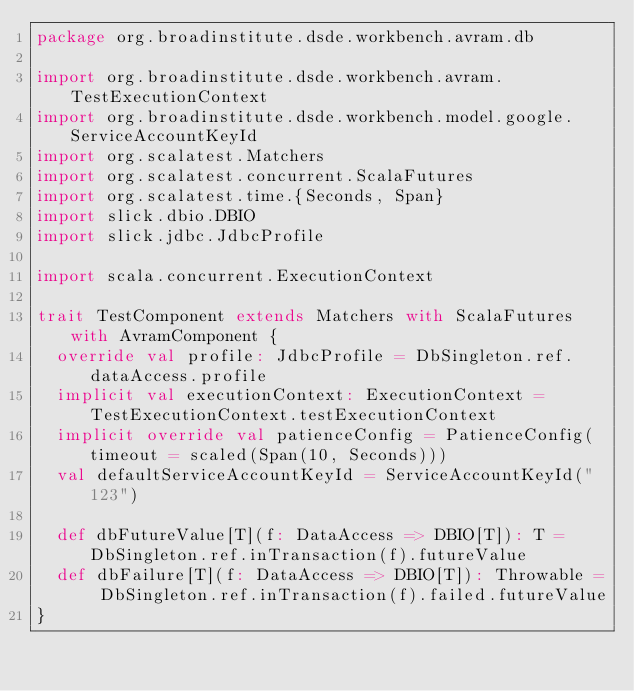Convert code to text. <code><loc_0><loc_0><loc_500><loc_500><_Scala_>package org.broadinstitute.dsde.workbench.avram.db

import org.broadinstitute.dsde.workbench.avram.TestExecutionContext
import org.broadinstitute.dsde.workbench.model.google.ServiceAccountKeyId
import org.scalatest.Matchers
import org.scalatest.concurrent.ScalaFutures
import org.scalatest.time.{Seconds, Span}
import slick.dbio.DBIO
import slick.jdbc.JdbcProfile

import scala.concurrent.ExecutionContext

trait TestComponent extends Matchers with ScalaFutures with AvramComponent {
  override val profile: JdbcProfile = DbSingleton.ref.dataAccess.profile
  implicit val executionContext: ExecutionContext = TestExecutionContext.testExecutionContext
  implicit override val patienceConfig = PatienceConfig(timeout = scaled(Span(10, Seconds)))
  val defaultServiceAccountKeyId = ServiceAccountKeyId("123")

  def dbFutureValue[T](f: DataAccess => DBIO[T]): T = DbSingleton.ref.inTransaction(f).futureValue
  def dbFailure[T](f: DataAccess => DBIO[T]): Throwable = DbSingleton.ref.inTransaction(f).failed.futureValue
}
</code> 